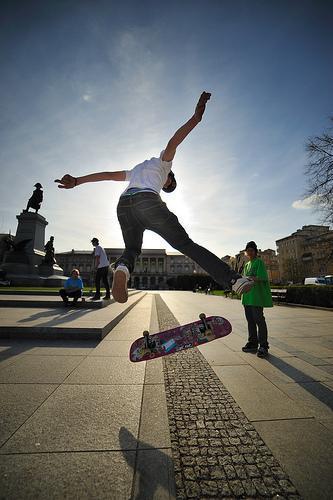How many people in green shirts?
Give a very brief answer. 1. How many men in white shirts?
Give a very brief answer. 2. How many leafless trees?
Give a very brief answer. 1. 